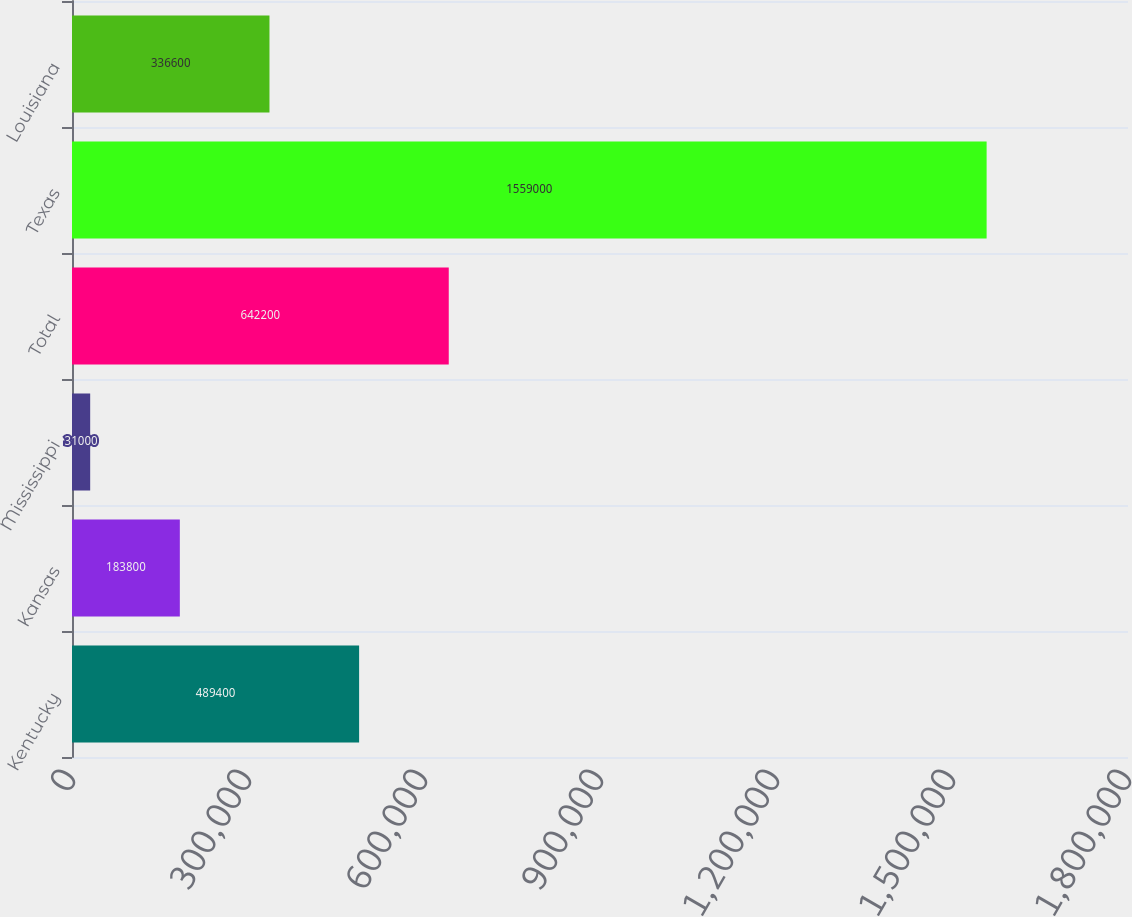Convert chart. <chart><loc_0><loc_0><loc_500><loc_500><bar_chart><fcel>Kentucky<fcel>Kansas<fcel>Mississippi<fcel>Total<fcel>Texas<fcel>Louisiana<nl><fcel>489400<fcel>183800<fcel>31000<fcel>642200<fcel>1.559e+06<fcel>336600<nl></chart> 